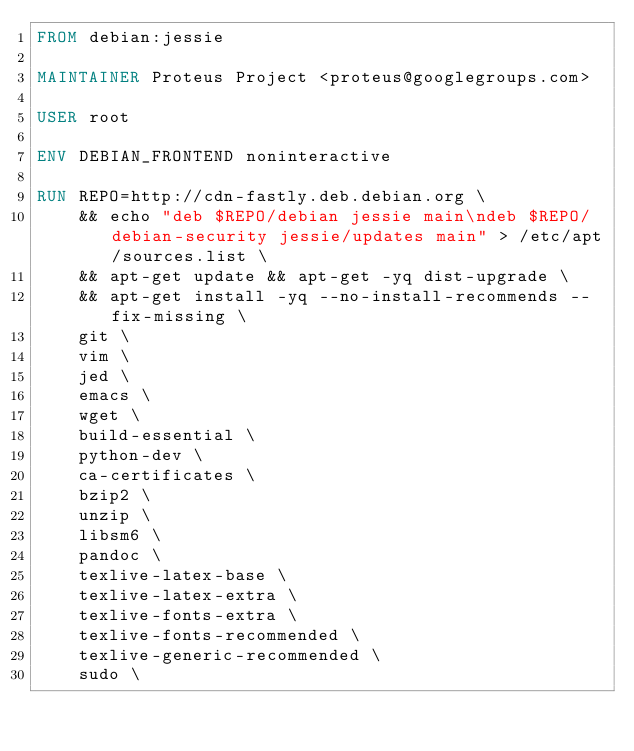Convert code to text. <code><loc_0><loc_0><loc_500><loc_500><_Dockerfile_>FROM debian:jessie

MAINTAINER Proteus Project <proteus@googlegroups.com>

USER root

ENV DEBIAN_FRONTEND noninteractive

RUN REPO=http://cdn-fastly.deb.debian.org \
    && echo "deb $REPO/debian jessie main\ndeb $REPO/debian-security jessie/updates main" > /etc/apt/sources.list \
    && apt-get update && apt-get -yq dist-upgrade \
    && apt-get install -yq --no-install-recommends --fix-missing \
    git \
    vim \
    jed \
    emacs \
    wget \
    build-essential \
    python-dev \
    ca-certificates \
    bzip2 \
    unzip \
    libsm6 \
    pandoc \
    texlive-latex-base \
    texlive-latex-extra \
    texlive-fonts-extra \
    texlive-fonts-recommended \
    texlive-generic-recommended \
    sudo \</code> 